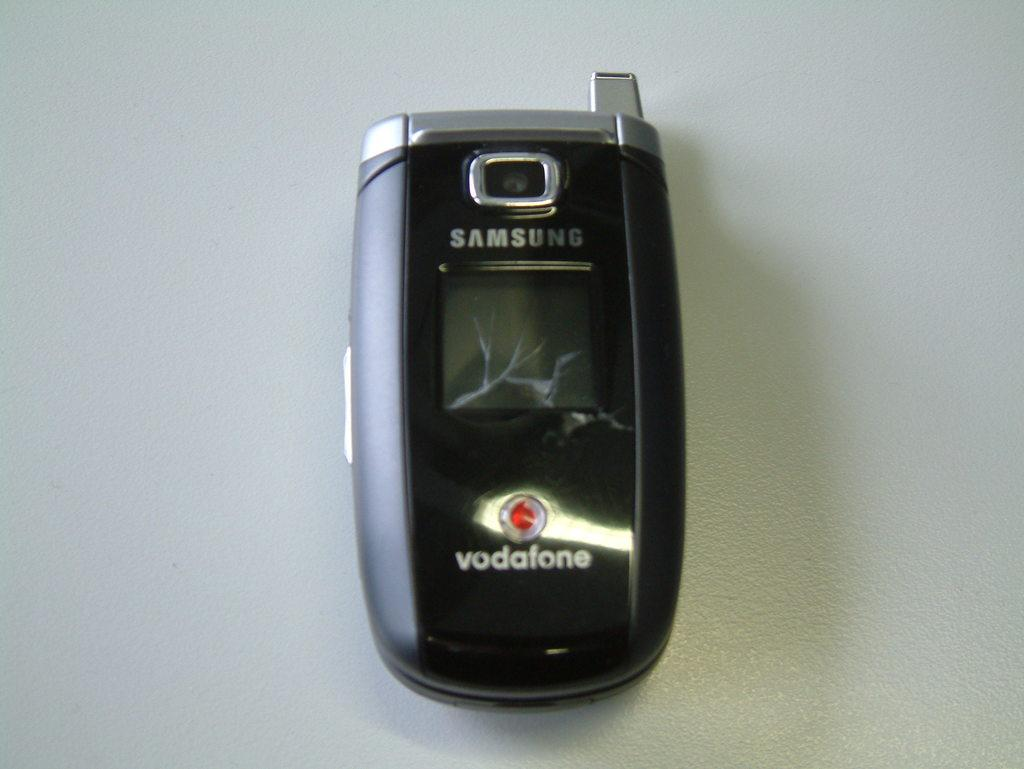<image>
Write a terse but informative summary of the picture. A black vodaphone by Samsung sits on a flat surface. 